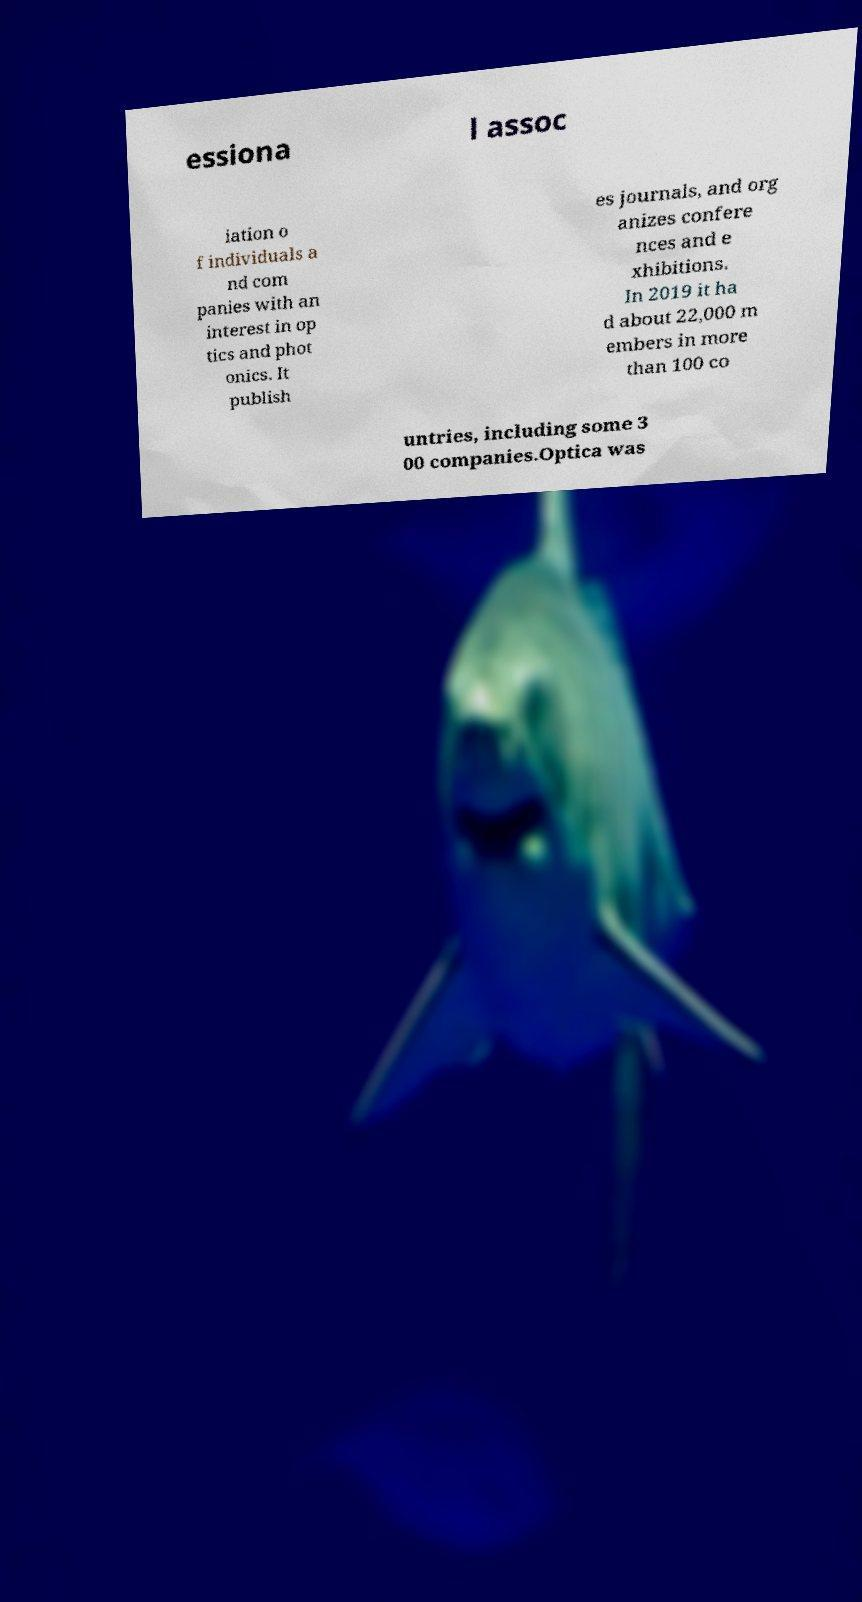What messages or text are displayed in this image? I need them in a readable, typed format. essiona l assoc iation o f individuals a nd com panies with an interest in op tics and phot onics. It publish es journals, and org anizes confere nces and e xhibitions. In 2019 it ha d about 22,000 m embers in more than 100 co untries, including some 3 00 companies.Optica was 